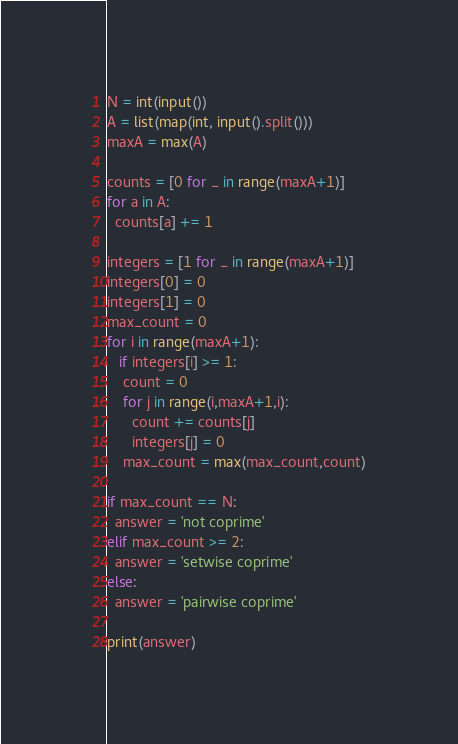<code> <loc_0><loc_0><loc_500><loc_500><_Python_>N = int(input())
A = list(map(int, input().split()))
maxA = max(A)

counts = [0 for _ in range(maxA+1)]
for a in A:
  counts[a] += 1

integers = [1 for _ in range(maxA+1)]
integers[0] = 0
integers[1] = 0
max_count = 0
for i in range(maxA+1):
   if integers[i] >= 1:
    count = 0
    for j in range(i,maxA+1,i):
      count += counts[j]
      integers[j] = 0
    max_count = max(max_count,count)

if max_count == N:
  answer = 'not coprime'
elif max_count >= 2:
  answer = 'setwise coprime'
else:
  answer = 'pairwise coprime'

print(answer)</code> 